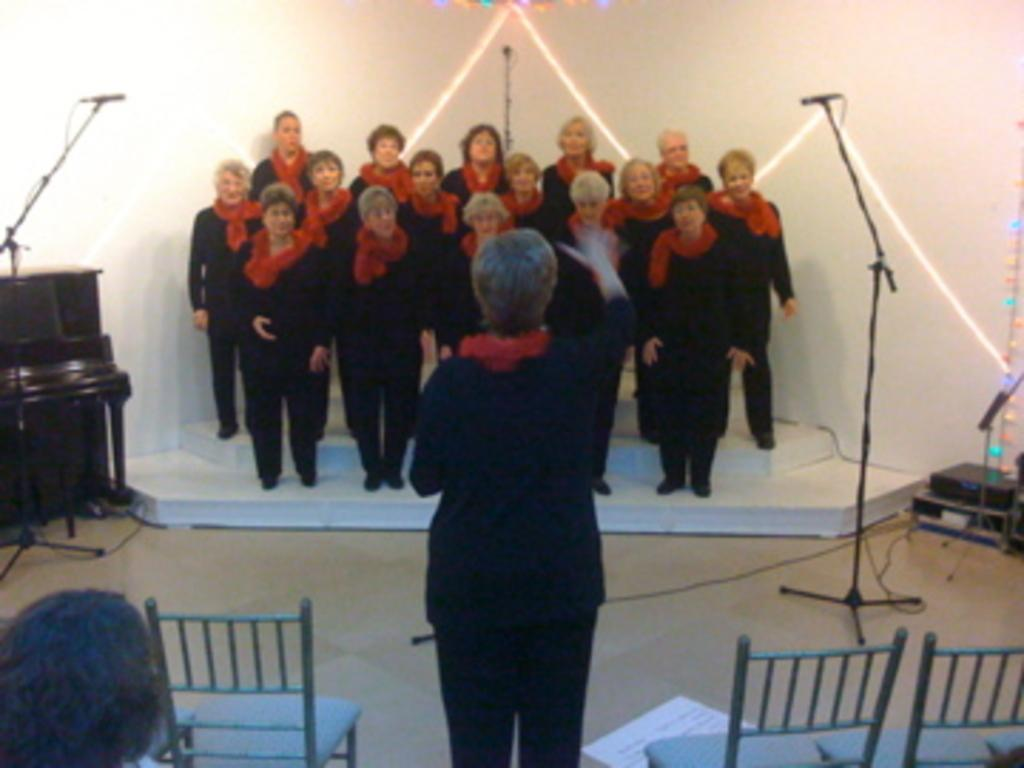What type of furniture is present in the image? There are chairs in the image. Can you describe the person standing in the image? A person is standing in the image, wearing a black dress. What objects are near the standing person? There are 2 microphones on either side of the standing person. What is happening in the background of the image? People are standing at the back of the image. What color is the background of the image? The background of the image is white. How does the camera move around in the image? There is no camera present in the image, so it cannot move around. What causes the person to move in the image? The person is not moving in the image; they are standing still. 